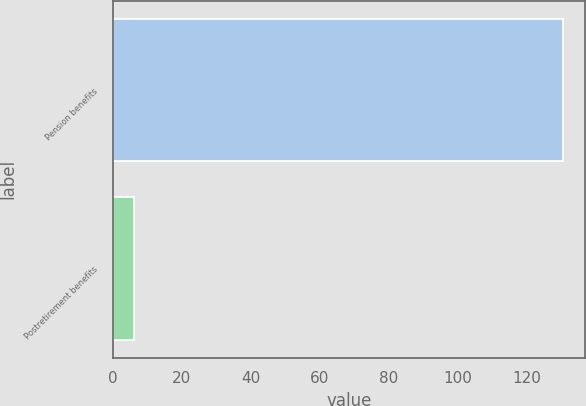<chart> <loc_0><loc_0><loc_500><loc_500><bar_chart><fcel>Pension benefits<fcel>Postretirement benefits<nl><fcel>130.3<fcel>6.1<nl></chart> 